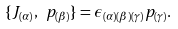Convert formula to latex. <formula><loc_0><loc_0><loc_500><loc_500>\{ J _ { ( \alpha ) } , \ p _ { ( \beta ) } \} = \epsilon _ { ( \alpha ) ( \beta ) ( \gamma ) } p _ { ( \gamma ) } .</formula> 